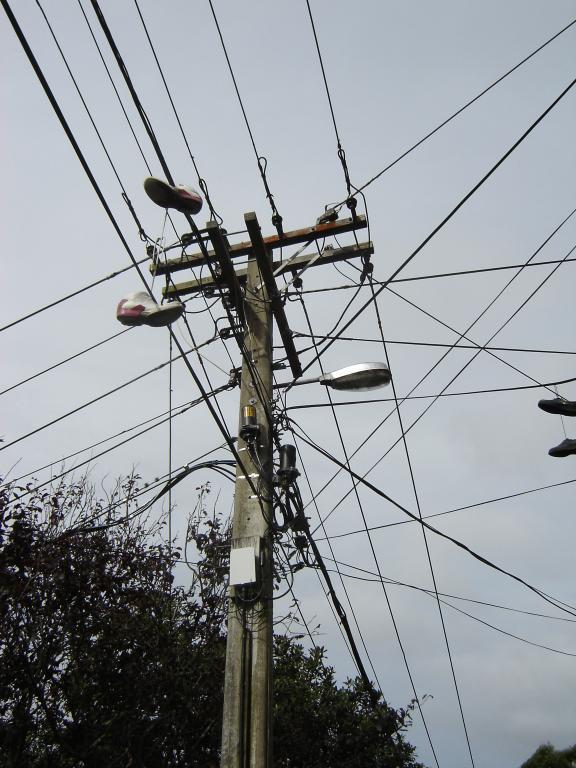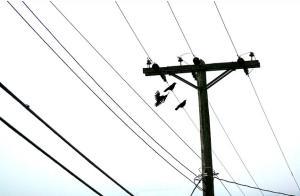The first image is the image on the left, the second image is the image on the right. For the images displayed, is the sentence "There are exactly two shoes hanging on the line in the image on the right" factually correct? Answer yes or no. No. 